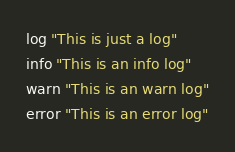<code> <loc_0><loc_0><loc_500><loc_500><_Bash_>
log "This is just a log"
info "This is an info log"
warn "This is an warn log"
error "This is an error log"
</code> 